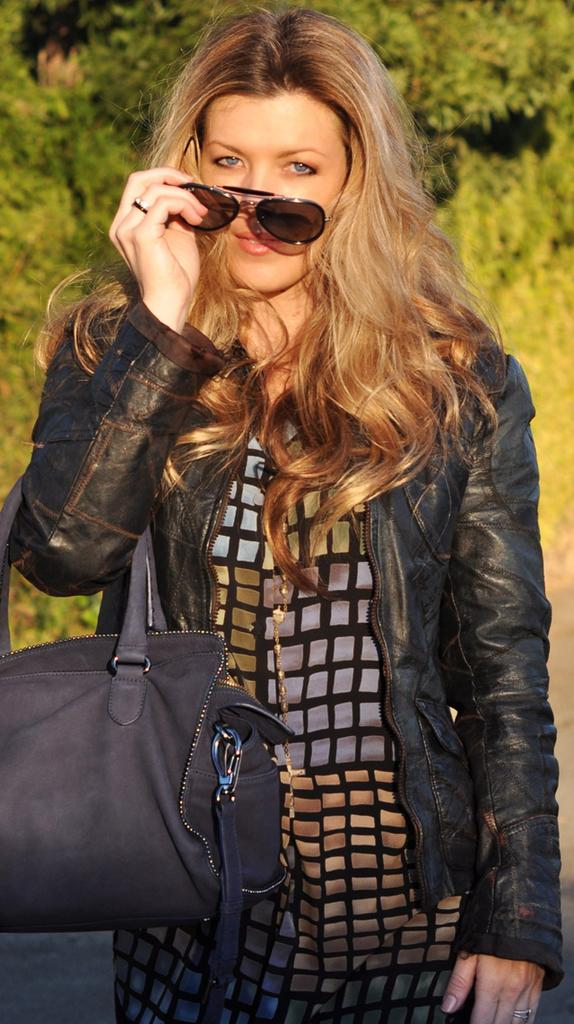Who is the main subject in the picture? There is a woman in the picture. What is the woman wearing? The woman is wearing a black jacket. What is the color of the woman's hair? The woman has blond hair. What can be seen in the background of the picture? There are trees in the background of the picture. What scientific experiment is the woman conducting in the picture? There is no indication of a scientific experiment in the picture; the woman is simply standing there. Who is the woman's partner in the picture? There is no partner present in the picture; it only shows a woman. 